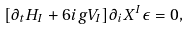<formula> <loc_0><loc_0><loc_500><loc_500>[ \partial _ { t } H _ { I } + 6 i g V _ { I } ] \partial _ { i } X ^ { I } \epsilon = 0 ,</formula> 